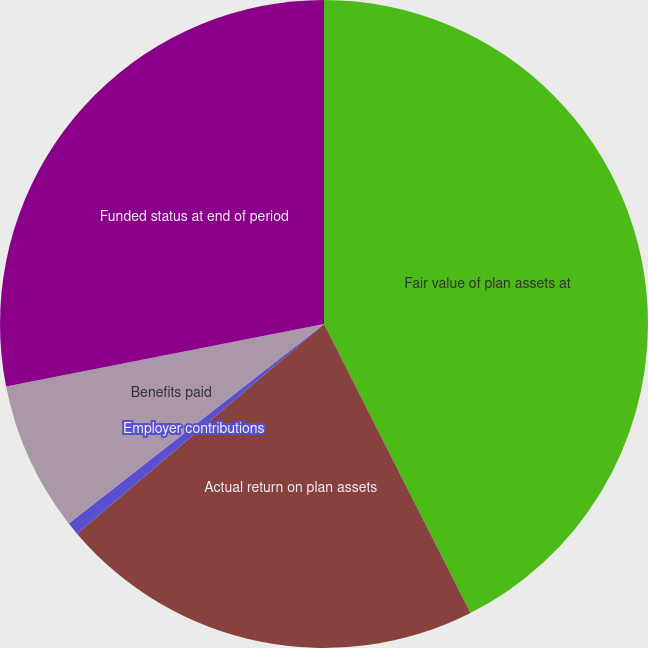Convert chart to OTSL. <chart><loc_0><loc_0><loc_500><loc_500><pie_chart><fcel>Fair value of plan assets at<fcel>Actual return on plan assets<fcel>Employer contributions<fcel>Benefits paid<fcel>Funded status at end of period<nl><fcel>42.53%<fcel>21.26%<fcel>0.64%<fcel>7.47%<fcel>28.09%<nl></chart> 